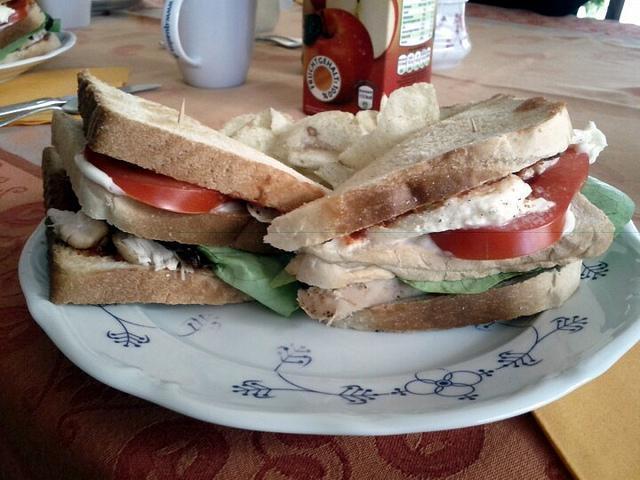What vegetable was used to make the side dish for this sandwich lunch?
Indicate the correct response and explain using: 'Answer: answer
Rationale: rationale.'
Options: Peas, endive, celery, potato. Answer: potato.
Rationale: The side dish is potato chips which are made of potatoes. 